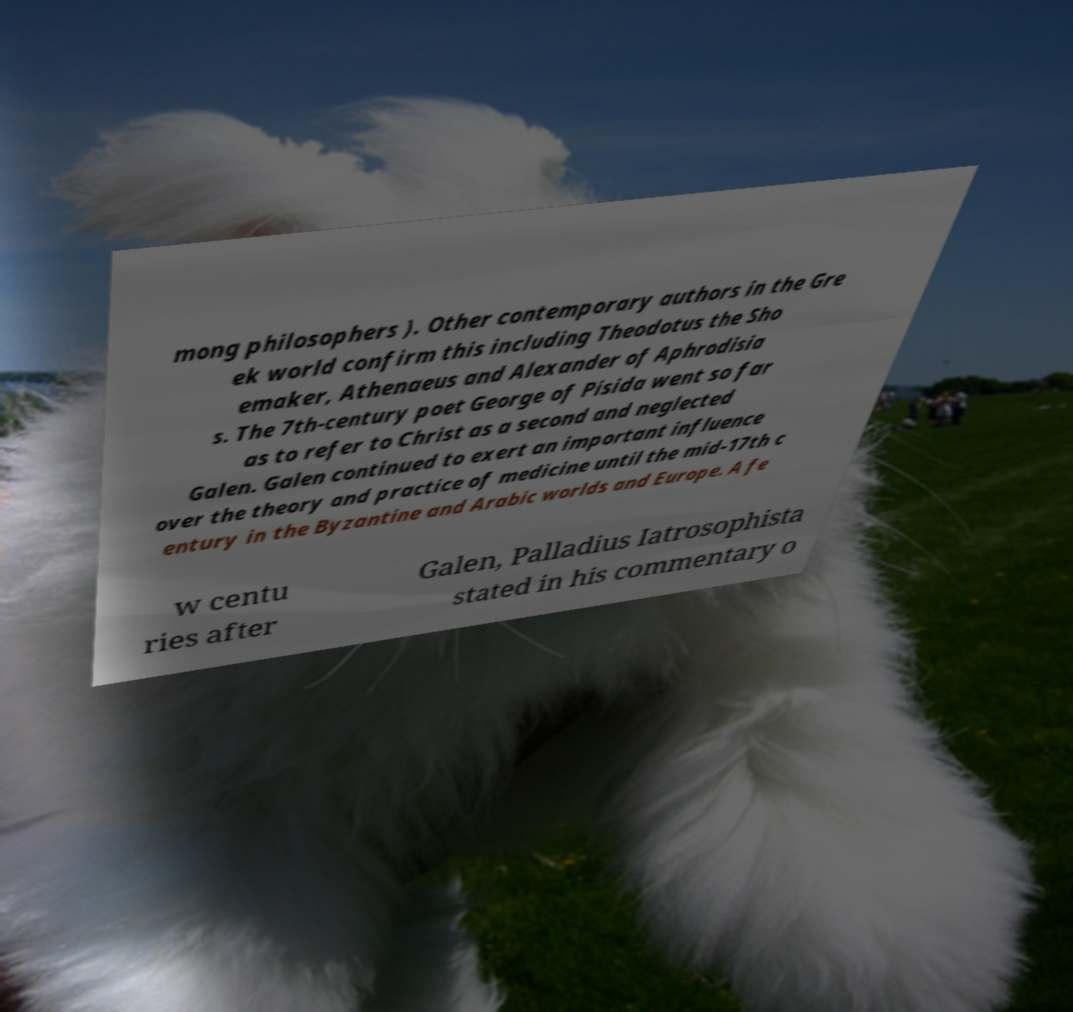Could you assist in decoding the text presented in this image and type it out clearly? mong philosophers ). Other contemporary authors in the Gre ek world confirm this including Theodotus the Sho emaker, Athenaeus and Alexander of Aphrodisia s. The 7th-century poet George of Pisida went so far as to refer to Christ as a second and neglected Galen. Galen continued to exert an important influence over the theory and practice of medicine until the mid-17th c entury in the Byzantine and Arabic worlds and Europe. A fe w centu ries after Galen, Palladius Iatrosophista stated in his commentary o 